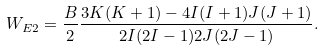<formula> <loc_0><loc_0><loc_500><loc_500>W _ { E 2 } = \frac { B } { 2 } \frac { 3 K ( K + 1 ) - 4 I ( I + 1 ) J ( J + 1 ) } { 2 I ( 2 I - 1 ) 2 J ( 2 J - 1 ) } .</formula> 